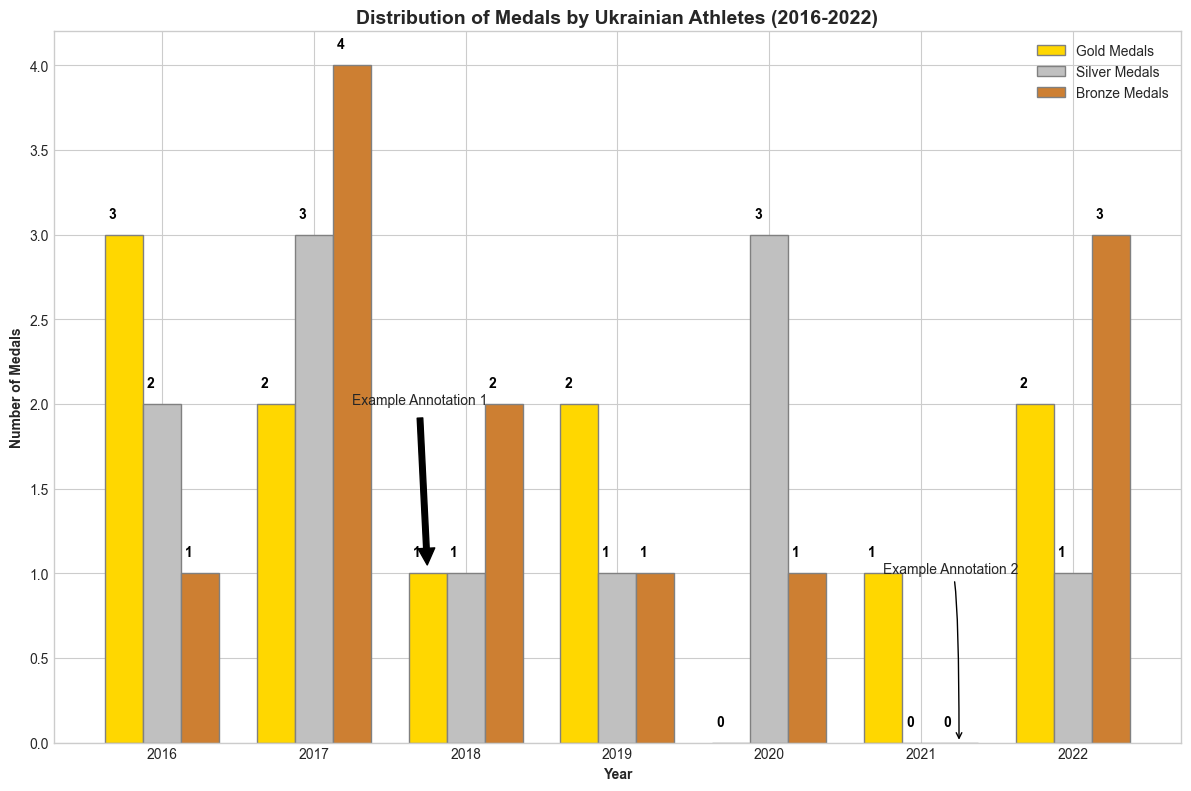Which year did Ukrainian athletes win the most medals overall? To find the year with the most medals, sum the gold, silver, and bronze medals for each year and compare the totals. For 2016: 3+2+1=6, 2017: 2+3+4=9, 2018: 1+1+2=4, 2019: 2+1+1=4, 2020: 0+3+1=4, 2021: 1+0+0=1, 2022: 2+1+3=6. 2017 has the highest total with 9 medals.
Answer: 2017 How many more gold medals were won in 2016 compared to 2018? Observe the heights of the gold medal bars for 2016 and 2018. In 2016, 3 gold medals were won, whereas in 2018, only 1 gold medal was won. The difference is 3 - 1 = 2.
Answer: 2 Which sport secured the most bronze medals and how many? Identify the year with the highest bar in the bronze medal section. In 2017, wrestling secured 4 bronze medals, which is the highest.
Answer: Wrestling with 4 bronze medals What is the total number of silver medals won between 2019 and 2021? Sum the silver medals from 2019, 2020, and 2021. For 2019: 1, 2020: 3, 2021: 0. Total is 1 + 3 + 0 = 4.
Answer: 4 Which type of medal had the lowest count in 2022? Compare the heights of the three bars for 2022. The gold bar has a height of 2, the silver has a height of 1, and the bronze has a height of 3. The silver medal count is the lowest at 1.
Answer: Silver In which year did boxing result in winning medals, and how many types of medals did they win that year? Identify the year associated with boxing and count the different types of medals. In 2018, boxing resulted in 1 gold, 1 silver, and 2 bronze medals, totaling 3 types.
Answer: 2018 and 3 types How many more total medals were won in gymnastics compared to karate? Compare the sums of gold, silver, and bronze medals for gymnastics (2016) and karate (2021). Gymnastics: 3+2+1=6, Karate: 1+0+0=1. The difference is 6 - 1 = 5.
Answer: 5 Which year had the same number of gold medals as the number of bronze medals in 2018? Bronze medals in 2018 equal 2. Check for years with 2 gold medals. In 2019 and 2022, athletes won 2 gold medals each.
Answer: 2019 and 2022 Which sport had the highest total medal count in the given years and how many? Sum the medals for each sport and compare. Wrestling in 2017: 2+3+4=9 (highest). Gymnastics in 2016: 3+2+1=6, Boxing in 2018: 1+1+2=4, Athletics in 2019: 2+1+1=4, Fencing in 2020: 0+3+1=4, Karate in 2021: 1+0+0=1, Weightlifting in 2022: 2+1+3=6.
Answer: Wrestling with 9 medals 